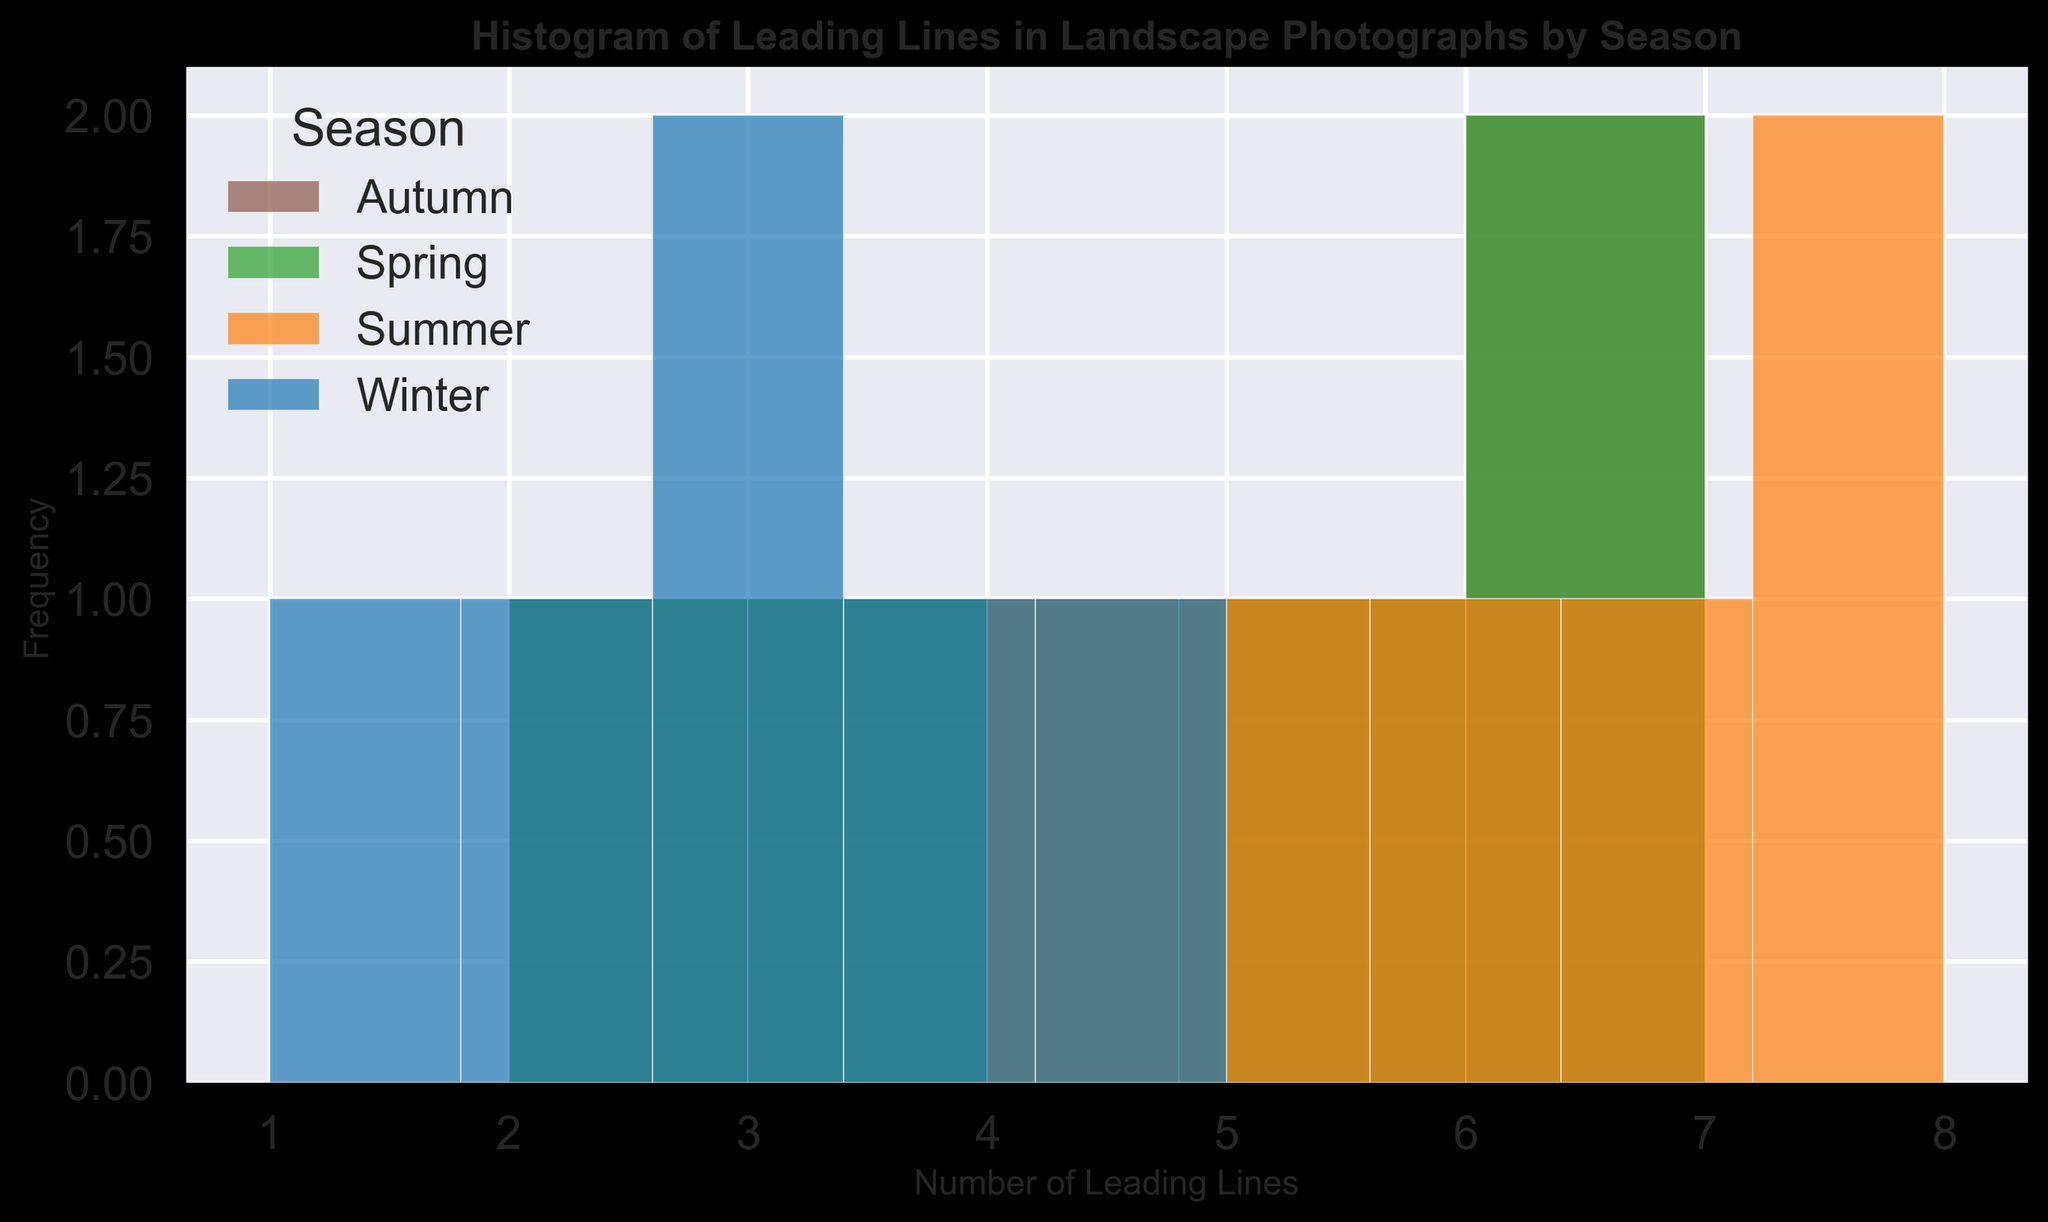What is the most frequent number of leading lines in Spring photographs? To find the most frequent number of leading lines in Spring photographs, observe the bar heights for Spring in the histogram. The tallest bar indicates the mode.
Answer: 4 What is the total number of leading lines captured in Summer photographs? To find this, count the total number of leading lines for Summer data points from the histogram or sum them directly from the data. (8 + 5 + 6 + 7 + 8 + 4) = 38
Answer: 38 Compare the maximum number of leading lines in Autumn with those in Winter. Which season has the higher maximum value? Identify the highest value in the Autumn bin and the highest value in the Winter bin. Autumn reaches a maximum of 7, while Winter only reaches a maximum of 5.
Answer: Autumn Is there a season that includes a photograph with just one leading line? Look at the histogram sections corresponding with the number of leading lines equal to 1 for each season. Only Winter includes a bar for 1 leading line.
Answer: Winter What is the range of leading lines in Spring photographs? Observe the minimum and maximum values of the leading lines for Spring. The minimum is 2, and the maximum is 7. The range is calculated by subtracting the minimum from the maximum (7 - 2).
Answer: 5 Which season shows the widest variety in the number of leading lines in photographs, indicated by the spread of the histogram bars? The more spread-out the histogram bars for a season are, the wider variety it shows. Summer has bars spread from 4 to 8, indicating the widest variety.
Answer: Summer 